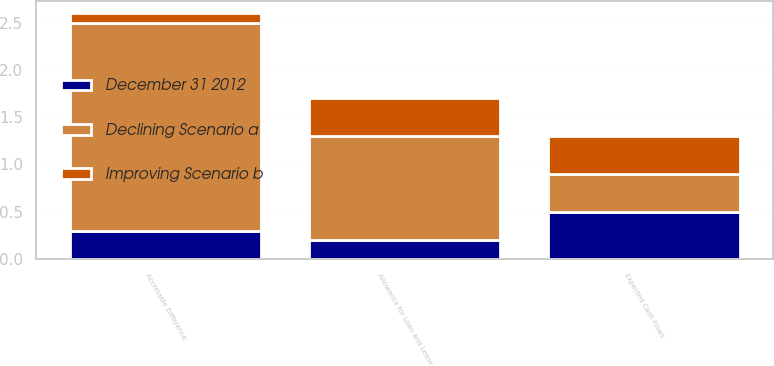Convert chart. <chart><loc_0><loc_0><loc_500><loc_500><stacked_bar_chart><ecel><fcel>Expected Cash Flows<fcel>Accretable Difference<fcel>Allowance for Loan and Lease<nl><fcel>Declining Scenario a<fcel>0.4<fcel>2.2<fcel>1.1<nl><fcel>Improving Scenario b<fcel>0.4<fcel>0.1<fcel>0.4<nl><fcel>December 31 2012<fcel>0.5<fcel>0.3<fcel>0.2<nl></chart> 